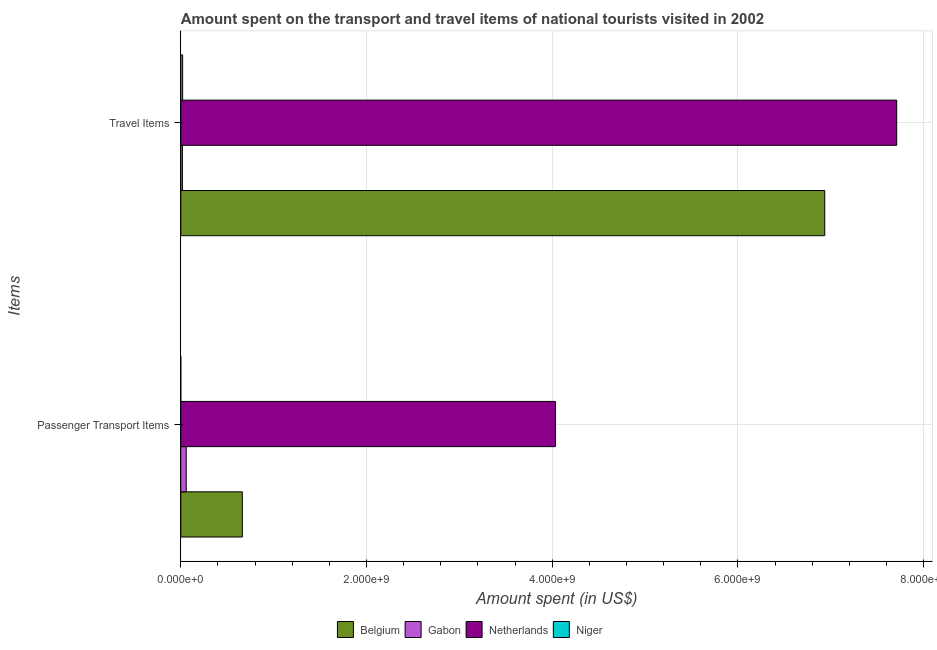How many groups of bars are there?
Provide a short and direct response. 2. Are the number of bars per tick equal to the number of legend labels?
Ensure brevity in your answer.  Yes. How many bars are there on the 2nd tick from the top?
Your answer should be compact. 4. How many bars are there on the 1st tick from the bottom?
Ensure brevity in your answer.  4. What is the label of the 2nd group of bars from the top?
Provide a succinct answer. Passenger Transport Items. What is the amount spent in travel items in Netherlands?
Keep it short and to the point. 7.71e+09. Across all countries, what is the maximum amount spent in travel items?
Ensure brevity in your answer.  7.71e+09. Across all countries, what is the minimum amount spent in travel items?
Your response must be concise. 1.80e+07. In which country was the amount spent in travel items maximum?
Offer a terse response. Netherlands. In which country was the amount spent in travel items minimum?
Provide a succinct answer. Gabon. What is the total amount spent in travel items in the graph?
Ensure brevity in your answer.  1.47e+1. What is the difference between the amount spent in travel items in Gabon and that in Niger?
Provide a succinct answer. -2.00e+06. What is the difference between the amount spent on passenger transport items in Gabon and the amount spent in travel items in Belgium?
Ensure brevity in your answer.  -6.88e+09. What is the average amount spent on passenger transport items per country?
Your response must be concise. 1.19e+09. What is the difference between the amount spent in travel items and amount spent on passenger transport items in Niger?
Ensure brevity in your answer.  1.98e+07. What is the ratio of the amount spent on passenger transport items in Niger to that in Belgium?
Provide a short and direct response. 0. Is the amount spent in travel items in Netherlands less than that in Gabon?
Provide a succinct answer. No. What does the 1st bar from the top in Travel Items represents?
Provide a succinct answer. Niger. How many bars are there?
Give a very brief answer. 8. How many countries are there in the graph?
Provide a succinct answer. 4. What is the difference between two consecutive major ticks on the X-axis?
Your answer should be very brief. 2.00e+09. Are the values on the major ticks of X-axis written in scientific E-notation?
Offer a very short reply. Yes. Does the graph contain any zero values?
Give a very brief answer. No. How are the legend labels stacked?
Your response must be concise. Horizontal. What is the title of the graph?
Ensure brevity in your answer.  Amount spent on the transport and travel items of national tourists visited in 2002. What is the label or title of the X-axis?
Provide a succinct answer. Amount spent (in US$). What is the label or title of the Y-axis?
Ensure brevity in your answer.  Items. What is the Amount spent (in US$) of Belgium in Passenger Transport Items?
Your answer should be very brief. 6.63e+08. What is the Amount spent (in US$) in Gabon in Passenger Transport Items?
Offer a very short reply. 5.90e+07. What is the Amount spent (in US$) in Netherlands in Passenger Transport Items?
Your response must be concise. 4.04e+09. What is the Amount spent (in US$) of Belgium in Travel Items?
Give a very brief answer. 6.94e+09. What is the Amount spent (in US$) in Gabon in Travel Items?
Ensure brevity in your answer.  1.80e+07. What is the Amount spent (in US$) of Netherlands in Travel Items?
Offer a very short reply. 7.71e+09. What is the Amount spent (in US$) in Niger in Travel Items?
Keep it short and to the point. 2.00e+07. Across all Items, what is the maximum Amount spent (in US$) of Belgium?
Ensure brevity in your answer.  6.94e+09. Across all Items, what is the maximum Amount spent (in US$) in Gabon?
Your answer should be very brief. 5.90e+07. Across all Items, what is the maximum Amount spent (in US$) of Netherlands?
Provide a short and direct response. 7.71e+09. Across all Items, what is the maximum Amount spent (in US$) of Niger?
Provide a succinct answer. 2.00e+07. Across all Items, what is the minimum Amount spent (in US$) in Belgium?
Make the answer very short. 6.63e+08. Across all Items, what is the minimum Amount spent (in US$) in Gabon?
Your answer should be compact. 1.80e+07. Across all Items, what is the minimum Amount spent (in US$) of Netherlands?
Make the answer very short. 4.04e+09. What is the total Amount spent (in US$) in Belgium in the graph?
Your answer should be very brief. 7.60e+09. What is the total Amount spent (in US$) in Gabon in the graph?
Give a very brief answer. 7.70e+07. What is the total Amount spent (in US$) in Netherlands in the graph?
Ensure brevity in your answer.  1.17e+1. What is the total Amount spent (in US$) in Niger in the graph?
Your response must be concise. 2.02e+07. What is the difference between the Amount spent (in US$) of Belgium in Passenger Transport Items and that in Travel Items?
Make the answer very short. -6.27e+09. What is the difference between the Amount spent (in US$) in Gabon in Passenger Transport Items and that in Travel Items?
Provide a short and direct response. 4.10e+07. What is the difference between the Amount spent (in US$) of Netherlands in Passenger Transport Items and that in Travel Items?
Ensure brevity in your answer.  -3.68e+09. What is the difference between the Amount spent (in US$) of Niger in Passenger Transport Items and that in Travel Items?
Offer a very short reply. -1.98e+07. What is the difference between the Amount spent (in US$) of Belgium in Passenger Transport Items and the Amount spent (in US$) of Gabon in Travel Items?
Your answer should be compact. 6.45e+08. What is the difference between the Amount spent (in US$) in Belgium in Passenger Transport Items and the Amount spent (in US$) in Netherlands in Travel Items?
Ensure brevity in your answer.  -7.05e+09. What is the difference between the Amount spent (in US$) in Belgium in Passenger Transport Items and the Amount spent (in US$) in Niger in Travel Items?
Offer a very short reply. 6.43e+08. What is the difference between the Amount spent (in US$) of Gabon in Passenger Transport Items and the Amount spent (in US$) of Netherlands in Travel Items?
Offer a terse response. -7.65e+09. What is the difference between the Amount spent (in US$) of Gabon in Passenger Transport Items and the Amount spent (in US$) of Niger in Travel Items?
Provide a succinct answer. 3.90e+07. What is the difference between the Amount spent (in US$) in Netherlands in Passenger Transport Items and the Amount spent (in US$) in Niger in Travel Items?
Give a very brief answer. 4.02e+09. What is the average Amount spent (in US$) of Belgium per Items?
Offer a terse response. 3.80e+09. What is the average Amount spent (in US$) in Gabon per Items?
Provide a short and direct response. 3.85e+07. What is the average Amount spent (in US$) in Netherlands per Items?
Ensure brevity in your answer.  5.87e+09. What is the average Amount spent (in US$) in Niger per Items?
Ensure brevity in your answer.  1.01e+07. What is the difference between the Amount spent (in US$) of Belgium and Amount spent (in US$) of Gabon in Passenger Transport Items?
Your answer should be compact. 6.04e+08. What is the difference between the Amount spent (in US$) of Belgium and Amount spent (in US$) of Netherlands in Passenger Transport Items?
Your response must be concise. -3.37e+09. What is the difference between the Amount spent (in US$) of Belgium and Amount spent (in US$) of Niger in Passenger Transport Items?
Your answer should be compact. 6.63e+08. What is the difference between the Amount spent (in US$) of Gabon and Amount spent (in US$) of Netherlands in Passenger Transport Items?
Offer a terse response. -3.98e+09. What is the difference between the Amount spent (in US$) of Gabon and Amount spent (in US$) of Niger in Passenger Transport Items?
Your answer should be very brief. 5.88e+07. What is the difference between the Amount spent (in US$) of Netherlands and Amount spent (in US$) of Niger in Passenger Transport Items?
Ensure brevity in your answer.  4.03e+09. What is the difference between the Amount spent (in US$) in Belgium and Amount spent (in US$) in Gabon in Travel Items?
Your response must be concise. 6.92e+09. What is the difference between the Amount spent (in US$) of Belgium and Amount spent (in US$) of Netherlands in Travel Items?
Ensure brevity in your answer.  -7.75e+08. What is the difference between the Amount spent (in US$) of Belgium and Amount spent (in US$) of Niger in Travel Items?
Your answer should be very brief. 6.92e+09. What is the difference between the Amount spent (in US$) of Gabon and Amount spent (in US$) of Netherlands in Travel Items?
Your response must be concise. -7.69e+09. What is the difference between the Amount spent (in US$) in Netherlands and Amount spent (in US$) in Niger in Travel Items?
Ensure brevity in your answer.  7.69e+09. What is the ratio of the Amount spent (in US$) of Belgium in Passenger Transport Items to that in Travel Items?
Your response must be concise. 0.1. What is the ratio of the Amount spent (in US$) of Gabon in Passenger Transport Items to that in Travel Items?
Your answer should be very brief. 3.28. What is the ratio of the Amount spent (in US$) of Netherlands in Passenger Transport Items to that in Travel Items?
Your answer should be compact. 0.52. What is the ratio of the Amount spent (in US$) of Niger in Passenger Transport Items to that in Travel Items?
Your answer should be very brief. 0.01. What is the difference between the highest and the second highest Amount spent (in US$) of Belgium?
Give a very brief answer. 6.27e+09. What is the difference between the highest and the second highest Amount spent (in US$) in Gabon?
Your answer should be compact. 4.10e+07. What is the difference between the highest and the second highest Amount spent (in US$) in Netherlands?
Keep it short and to the point. 3.68e+09. What is the difference between the highest and the second highest Amount spent (in US$) in Niger?
Your answer should be compact. 1.98e+07. What is the difference between the highest and the lowest Amount spent (in US$) in Belgium?
Ensure brevity in your answer.  6.27e+09. What is the difference between the highest and the lowest Amount spent (in US$) in Gabon?
Keep it short and to the point. 4.10e+07. What is the difference between the highest and the lowest Amount spent (in US$) of Netherlands?
Make the answer very short. 3.68e+09. What is the difference between the highest and the lowest Amount spent (in US$) in Niger?
Offer a terse response. 1.98e+07. 